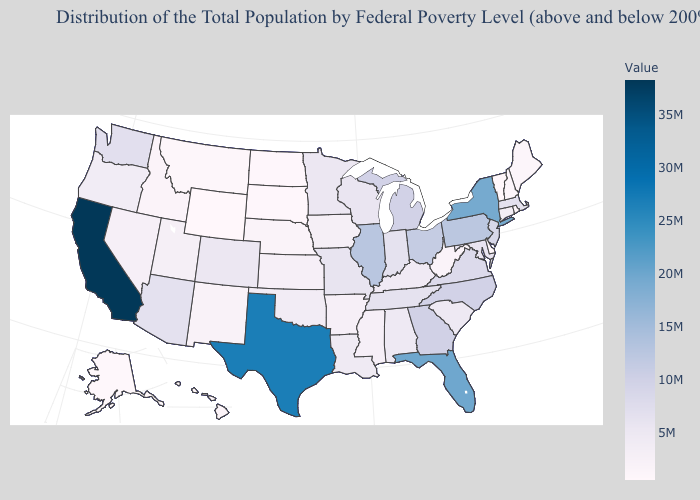Among the states that border South Carolina , which have the lowest value?
Quick response, please. North Carolina. Which states hav the highest value in the MidWest?
Short answer required. Illinois. Does the map have missing data?
Short answer required. No. Does the map have missing data?
Write a very short answer. No. 